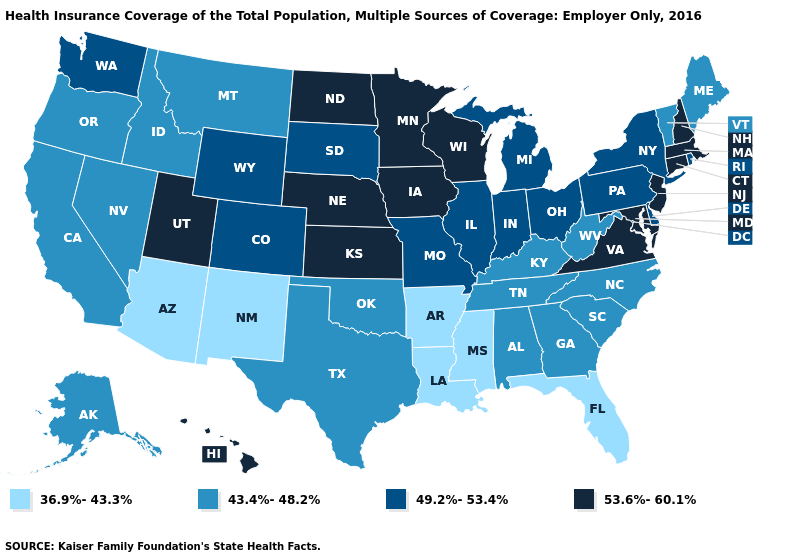Is the legend a continuous bar?
Answer briefly. No. Does the map have missing data?
Give a very brief answer. No. What is the value of North Carolina?
Concise answer only. 43.4%-48.2%. What is the value of Arizona?
Give a very brief answer. 36.9%-43.3%. Does Michigan have a lower value than New Hampshire?
Concise answer only. Yes. What is the highest value in the USA?
Be succinct. 53.6%-60.1%. What is the value of Utah?
Give a very brief answer. 53.6%-60.1%. Does New York have the lowest value in the USA?
Short answer required. No. Name the states that have a value in the range 49.2%-53.4%?
Be succinct. Colorado, Delaware, Illinois, Indiana, Michigan, Missouri, New York, Ohio, Pennsylvania, Rhode Island, South Dakota, Washington, Wyoming. What is the value of New Mexico?
Be succinct. 36.9%-43.3%. Does Delaware have the lowest value in the South?
Write a very short answer. No. What is the value of California?
Answer briefly. 43.4%-48.2%. What is the lowest value in states that border Kentucky?
Keep it brief. 43.4%-48.2%. Name the states that have a value in the range 49.2%-53.4%?
Short answer required. Colorado, Delaware, Illinois, Indiana, Michigan, Missouri, New York, Ohio, Pennsylvania, Rhode Island, South Dakota, Washington, Wyoming. Name the states that have a value in the range 53.6%-60.1%?
Answer briefly. Connecticut, Hawaii, Iowa, Kansas, Maryland, Massachusetts, Minnesota, Nebraska, New Hampshire, New Jersey, North Dakota, Utah, Virginia, Wisconsin. 